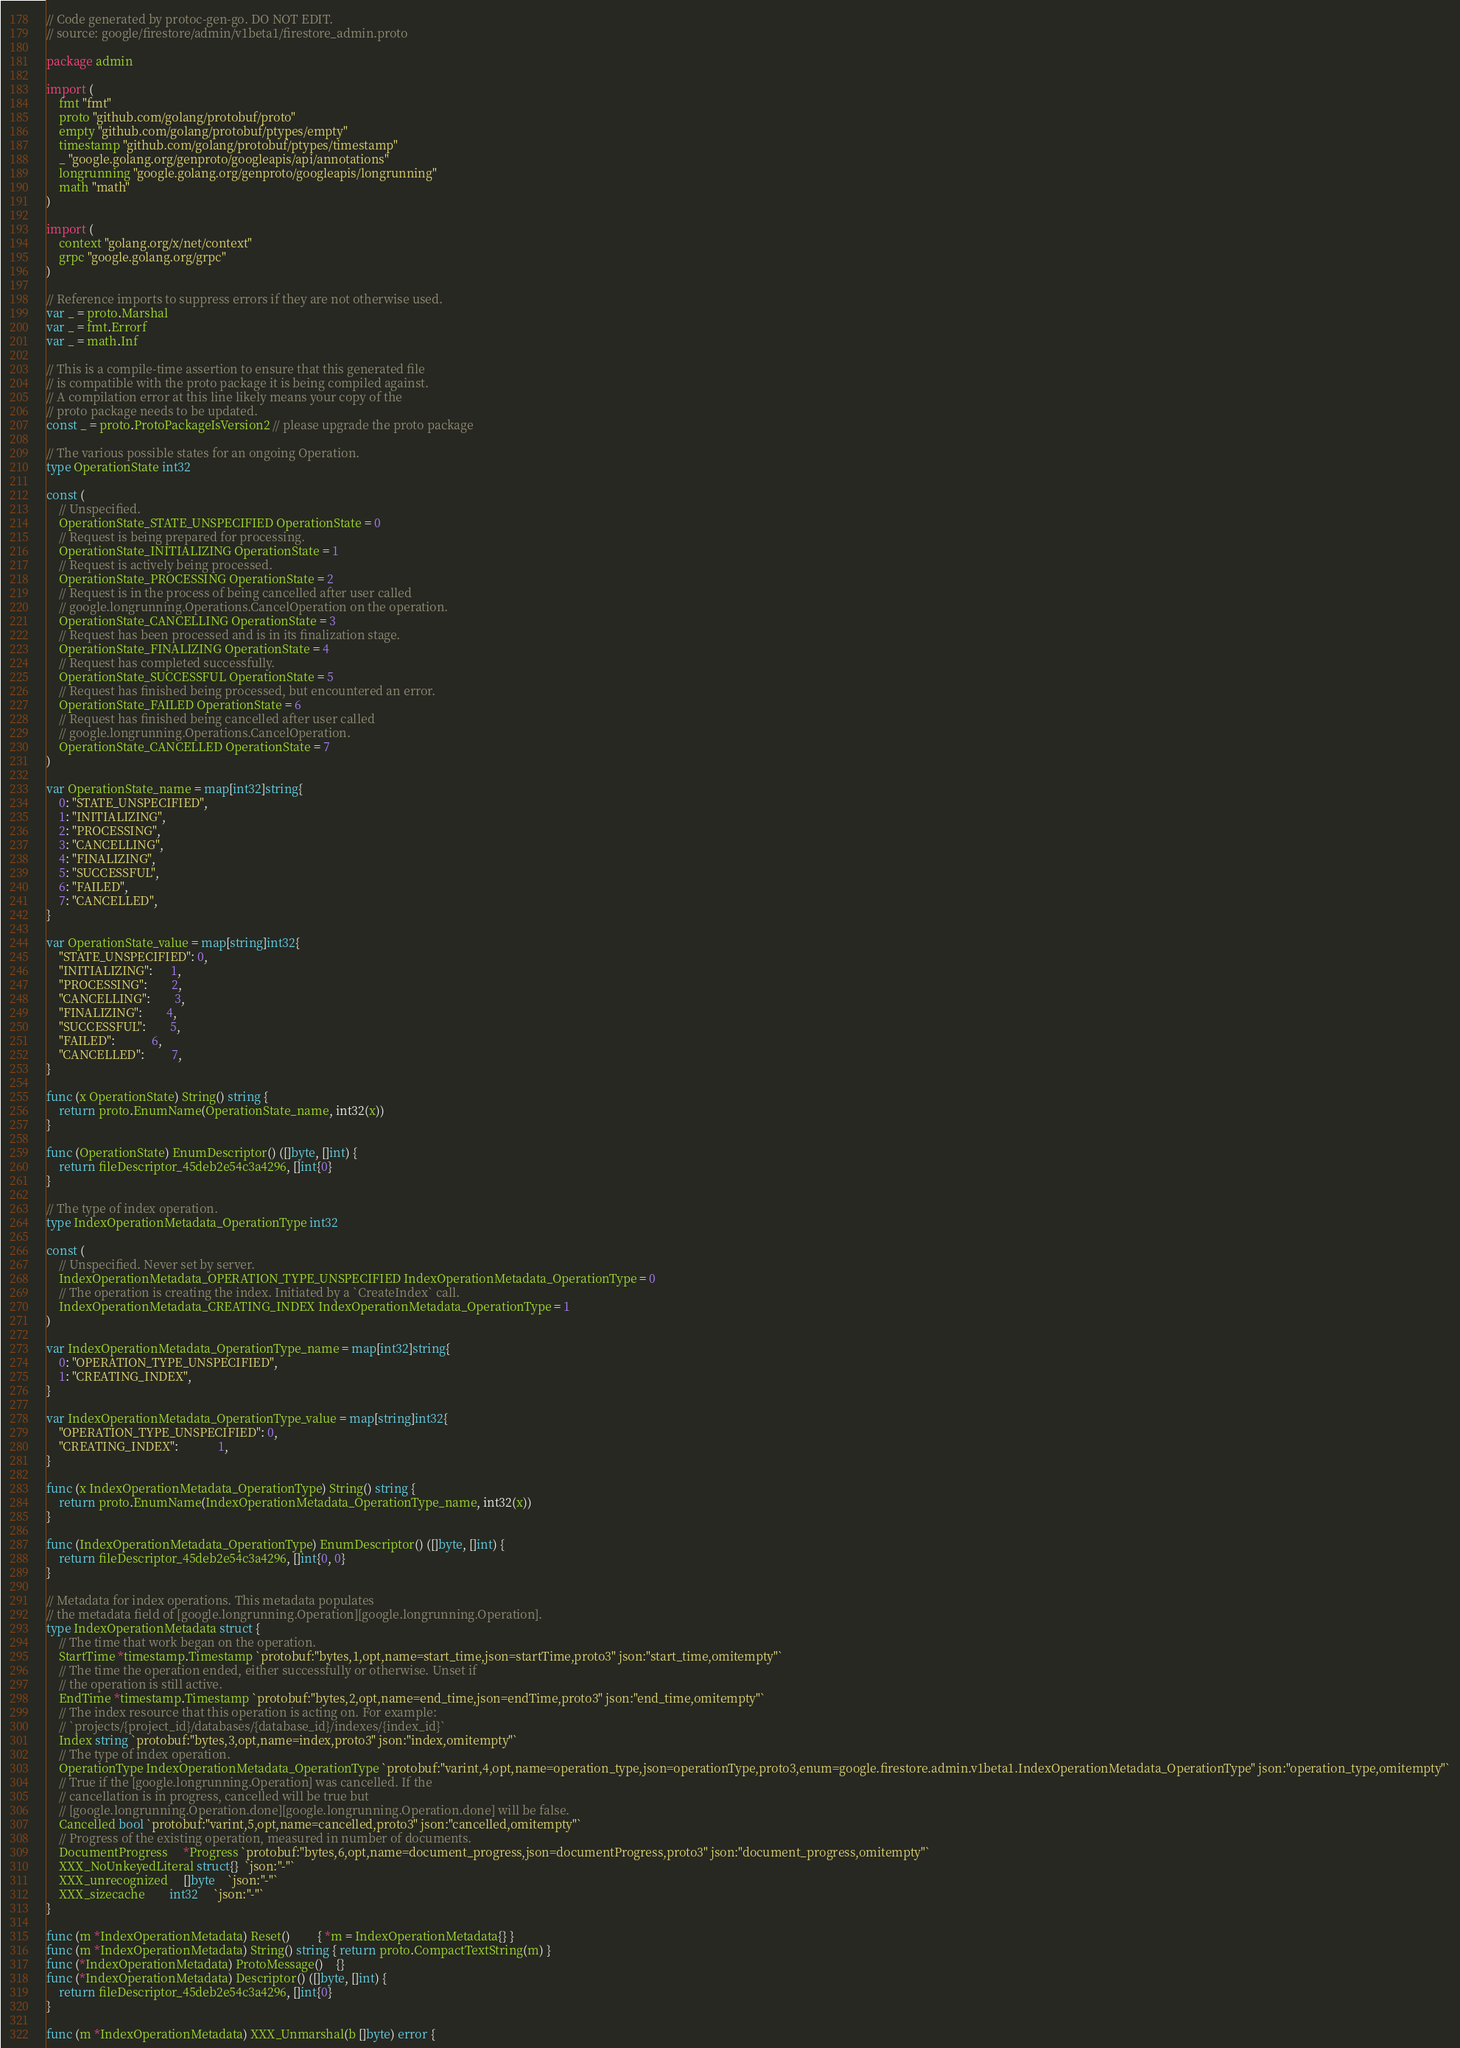Convert code to text. <code><loc_0><loc_0><loc_500><loc_500><_Go_>// Code generated by protoc-gen-go. DO NOT EDIT.
// source: google/firestore/admin/v1beta1/firestore_admin.proto

package admin

import (
	fmt "fmt"
	proto "github.com/golang/protobuf/proto"
	empty "github.com/golang/protobuf/ptypes/empty"
	timestamp "github.com/golang/protobuf/ptypes/timestamp"
	_ "google.golang.org/genproto/googleapis/api/annotations"
	longrunning "google.golang.org/genproto/googleapis/longrunning"
	math "math"
)

import (
	context "golang.org/x/net/context"
	grpc "google.golang.org/grpc"
)

// Reference imports to suppress errors if they are not otherwise used.
var _ = proto.Marshal
var _ = fmt.Errorf
var _ = math.Inf

// This is a compile-time assertion to ensure that this generated file
// is compatible with the proto package it is being compiled against.
// A compilation error at this line likely means your copy of the
// proto package needs to be updated.
const _ = proto.ProtoPackageIsVersion2 // please upgrade the proto package

// The various possible states for an ongoing Operation.
type OperationState int32

const (
	// Unspecified.
	OperationState_STATE_UNSPECIFIED OperationState = 0
	// Request is being prepared for processing.
	OperationState_INITIALIZING OperationState = 1
	// Request is actively being processed.
	OperationState_PROCESSING OperationState = 2
	// Request is in the process of being cancelled after user called
	// google.longrunning.Operations.CancelOperation on the operation.
	OperationState_CANCELLING OperationState = 3
	// Request has been processed and is in its finalization stage.
	OperationState_FINALIZING OperationState = 4
	// Request has completed successfully.
	OperationState_SUCCESSFUL OperationState = 5
	// Request has finished being processed, but encountered an error.
	OperationState_FAILED OperationState = 6
	// Request has finished being cancelled after user called
	// google.longrunning.Operations.CancelOperation.
	OperationState_CANCELLED OperationState = 7
)

var OperationState_name = map[int32]string{
	0: "STATE_UNSPECIFIED",
	1: "INITIALIZING",
	2: "PROCESSING",
	3: "CANCELLING",
	4: "FINALIZING",
	5: "SUCCESSFUL",
	6: "FAILED",
	7: "CANCELLED",
}

var OperationState_value = map[string]int32{
	"STATE_UNSPECIFIED": 0,
	"INITIALIZING":      1,
	"PROCESSING":        2,
	"CANCELLING":        3,
	"FINALIZING":        4,
	"SUCCESSFUL":        5,
	"FAILED":            6,
	"CANCELLED":         7,
}

func (x OperationState) String() string {
	return proto.EnumName(OperationState_name, int32(x))
}

func (OperationState) EnumDescriptor() ([]byte, []int) {
	return fileDescriptor_45deb2e54c3a4296, []int{0}
}

// The type of index operation.
type IndexOperationMetadata_OperationType int32

const (
	// Unspecified. Never set by server.
	IndexOperationMetadata_OPERATION_TYPE_UNSPECIFIED IndexOperationMetadata_OperationType = 0
	// The operation is creating the index. Initiated by a `CreateIndex` call.
	IndexOperationMetadata_CREATING_INDEX IndexOperationMetadata_OperationType = 1
)

var IndexOperationMetadata_OperationType_name = map[int32]string{
	0: "OPERATION_TYPE_UNSPECIFIED",
	1: "CREATING_INDEX",
}

var IndexOperationMetadata_OperationType_value = map[string]int32{
	"OPERATION_TYPE_UNSPECIFIED": 0,
	"CREATING_INDEX":             1,
}

func (x IndexOperationMetadata_OperationType) String() string {
	return proto.EnumName(IndexOperationMetadata_OperationType_name, int32(x))
}

func (IndexOperationMetadata_OperationType) EnumDescriptor() ([]byte, []int) {
	return fileDescriptor_45deb2e54c3a4296, []int{0, 0}
}

// Metadata for index operations. This metadata populates
// the metadata field of [google.longrunning.Operation][google.longrunning.Operation].
type IndexOperationMetadata struct {
	// The time that work began on the operation.
	StartTime *timestamp.Timestamp `protobuf:"bytes,1,opt,name=start_time,json=startTime,proto3" json:"start_time,omitempty"`
	// The time the operation ended, either successfully or otherwise. Unset if
	// the operation is still active.
	EndTime *timestamp.Timestamp `protobuf:"bytes,2,opt,name=end_time,json=endTime,proto3" json:"end_time,omitempty"`
	// The index resource that this operation is acting on. For example:
	// `projects/{project_id}/databases/{database_id}/indexes/{index_id}`
	Index string `protobuf:"bytes,3,opt,name=index,proto3" json:"index,omitempty"`
	// The type of index operation.
	OperationType IndexOperationMetadata_OperationType `protobuf:"varint,4,opt,name=operation_type,json=operationType,proto3,enum=google.firestore.admin.v1beta1.IndexOperationMetadata_OperationType" json:"operation_type,omitempty"`
	// True if the [google.longrunning.Operation] was cancelled. If the
	// cancellation is in progress, cancelled will be true but
	// [google.longrunning.Operation.done][google.longrunning.Operation.done] will be false.
	Cancelled bool `protobuf:"varint,5,opt,name=cancelled,proto3" json:"cancelled,omitempty"`
	// Progress of the existing operation, measured in number of documents.
	DocumentProgress     *Progress `protobuf:"bytes,6,opt,name=document_progress,json=documentProgress,proto3" json:"document_progress,omitempty"`
	XXX_NoUnkeyedLiteral struct{}  `json:"-"`
	XXX_unrecognized     []byte    `json:"-"`
	XXX_sizecache        int32     `json:"-"`
}

func (m *IndexOperationMetadata) Reset()         { *m = IndexOperationMetadata{} }
func (m *IndexOperationMetadata) String() string { return proto.CompactTextString(m) }
func (*IndexOperationMetadata) ProtoMessage()    {}
func (*IndexOperationMetadata) Descriptor() ([]byte, []int) {
	return fileDescriptor_45deb2e54c3a4296, []int{0}
}

func (m *IndexOperationMetadata) XXX_Unmarshal(b []byte) error {</code> 